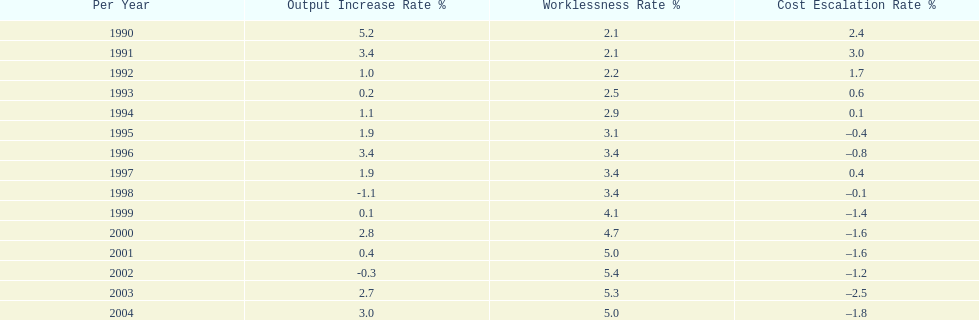Were the highest unemployment rates in japan before or after the year 2000? After. 